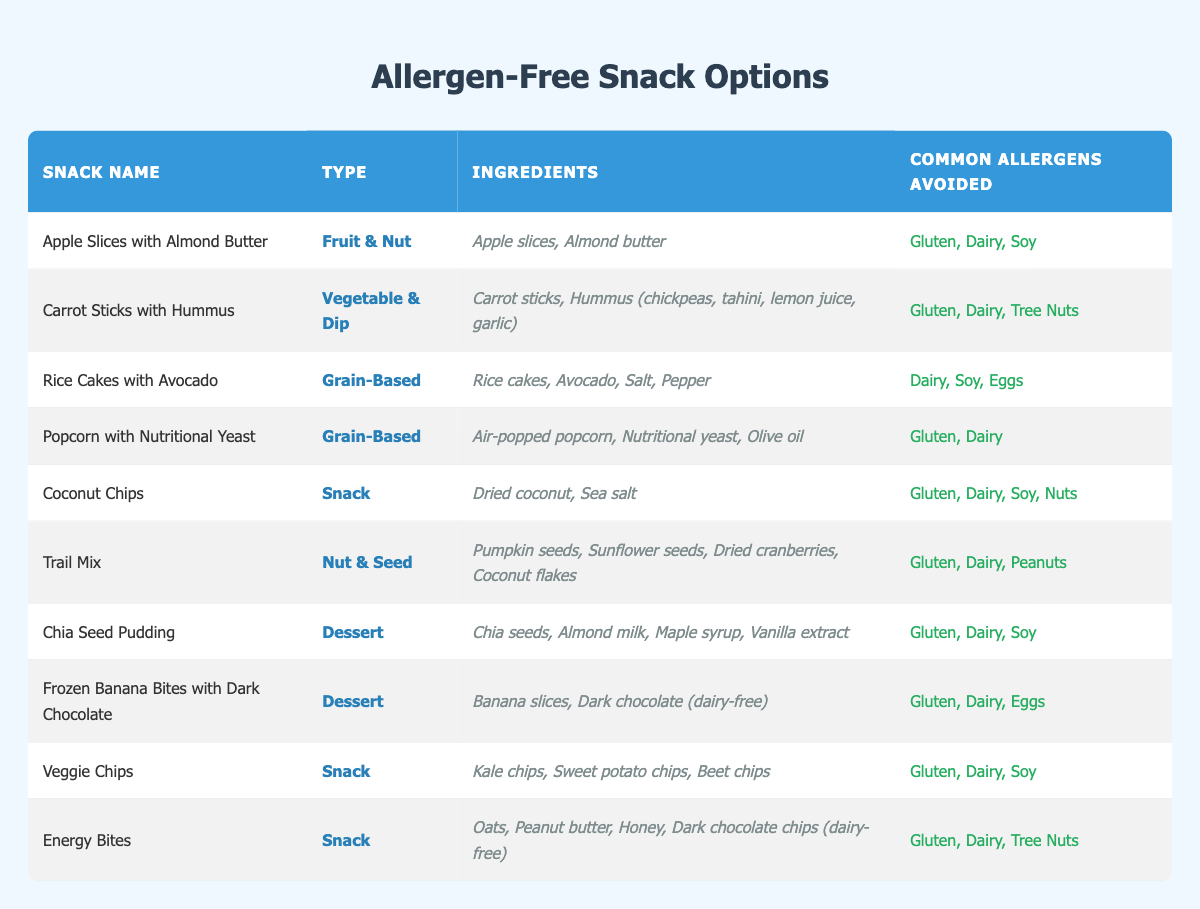What type of snack is "Rice Cakes with Avocado"? According to the table, "Rice Cakes with Avocado" falls under the "Grain-Based" category.
Answer: Grain-Based How many snacks avoid "Dairy" as a common allergen? By looking at the table, the snacks that avoid "Dairy" are: "Rice Cakes with Avocado," "Popcorn with Nutritional Yeast," "Coconut Chips," "Trail Mix," "Chia Seed Pudding," "Frozen Banana Bites with Dark Chocolate," "Veggie Chips," and "Energy Bites." This totals to 8 snacks.
Answer: 8 Are there any snacks that include both "Peanuts" and "Gluten" allergens? Checking the table reveals that "Trail Mix" avoids "Peanuts" and "Gluten," and "Energy Bites" specifically includes "Peanuts," which indicates a mix. Therefore, we confirm that it's impossible to have a snack containing both allergens at the same time.
Answer: No Which snack has the most ingredients listed? Reviewing the list, "Carrot Sticks with Hummus" has the most ingredients: "Carrot sticks, Hummus (chickpeas, tahini, lemon juice, garlic)" which counts as 4 ingredients, tying with "Energy Bites" but the latter has a slightly simpler description due to fewer components.
Answer: Carrot Sticks with Hummus What are the total allergens avoided by "Trail Mix"? The allergens avoided by "Trail Mix" are "Gluten," "Dairy," and "Peanuts." Since there are three listed, we can calculate the total directly by counting.
Answer: 3 Which snack types do not contain any nuts? In the table, "Rice Cakes with Avocado," "Popcorn with Nutritional Yeast," "Chia Seed Pudding," and "Veggie Chips" do not contain any nuts, being pure vegetable or grain-based snacks. Hence, 4 snack types are confirmed nut-free.
Answer: 4 Is "Coconut Chips" classified as a dessert? The classification for "Coconut Chips" is found under the "Snack" category in the table, not as a dessert. Therefore, it’s not classified that way.
Answer: No What is the total number of snack types represented in the table? Analyzing the types, we find: "Fruit & Nut," "Vegetable & Dip," "Grain-Based," "Snack," "Nut & Seed," and "Dessert." This leads to a total of 6 distinct snack types.
Answer: 6 Which snack contains "Almond milk" as an ingredient? By examining the table, "Chia Seed Pudding" is the only snack that lists "Almond milk" among its ingredients.
Answer: Chia Seed Pudding 